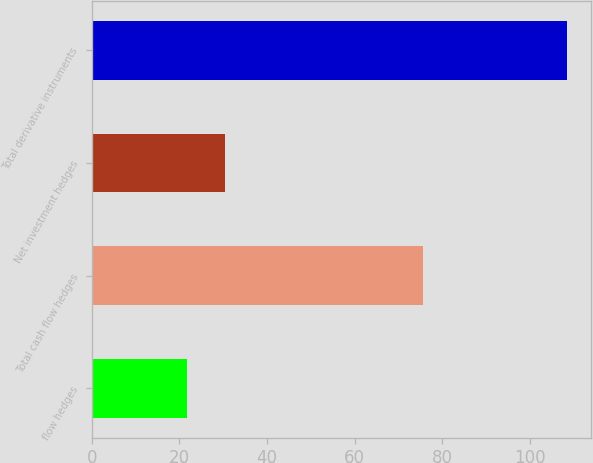<chart> <loc_0><loc_0><loc_500><loc_500><bar_chart><fcel>flow hedges<fcel>Total cash flow hedges<fcel>Net investment hedges<fcel>Total derivative instruments<nl><fcel>21.8<fcel>75.6<fcel>30.48<fcel>108.6<nl></chart> 